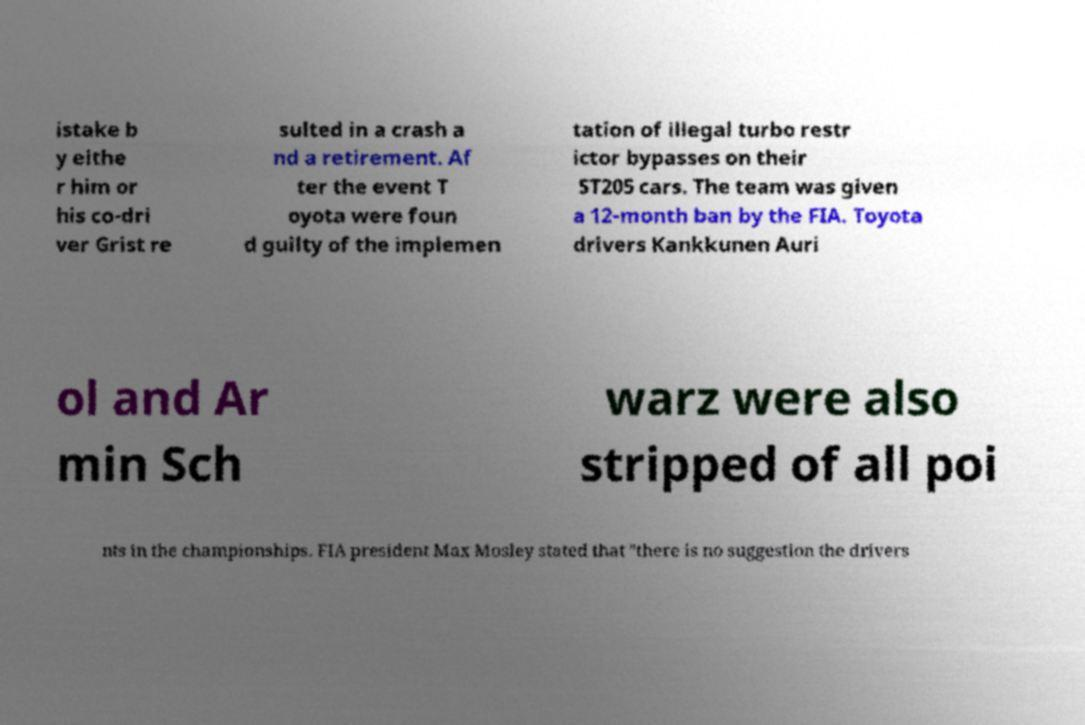What messages or text are displayed in this image? I need them in a readable, typed format. istake b y eithe r him or his co-dri ver Grist re sulted in a crash a nd a retirement. Af ter the event T oyota were foun d guilty of the implemen tation of illegal turbo restr ictor bypasses on their ST205 cars. The team was given a 12-month ban by the FIA. Toyota drivers Kankkunen Auri ol and Ar min Sch warz were also stripped of all poi nts in the championships. FIA president Max Mosley stated that "there is no suggestion the drivers 